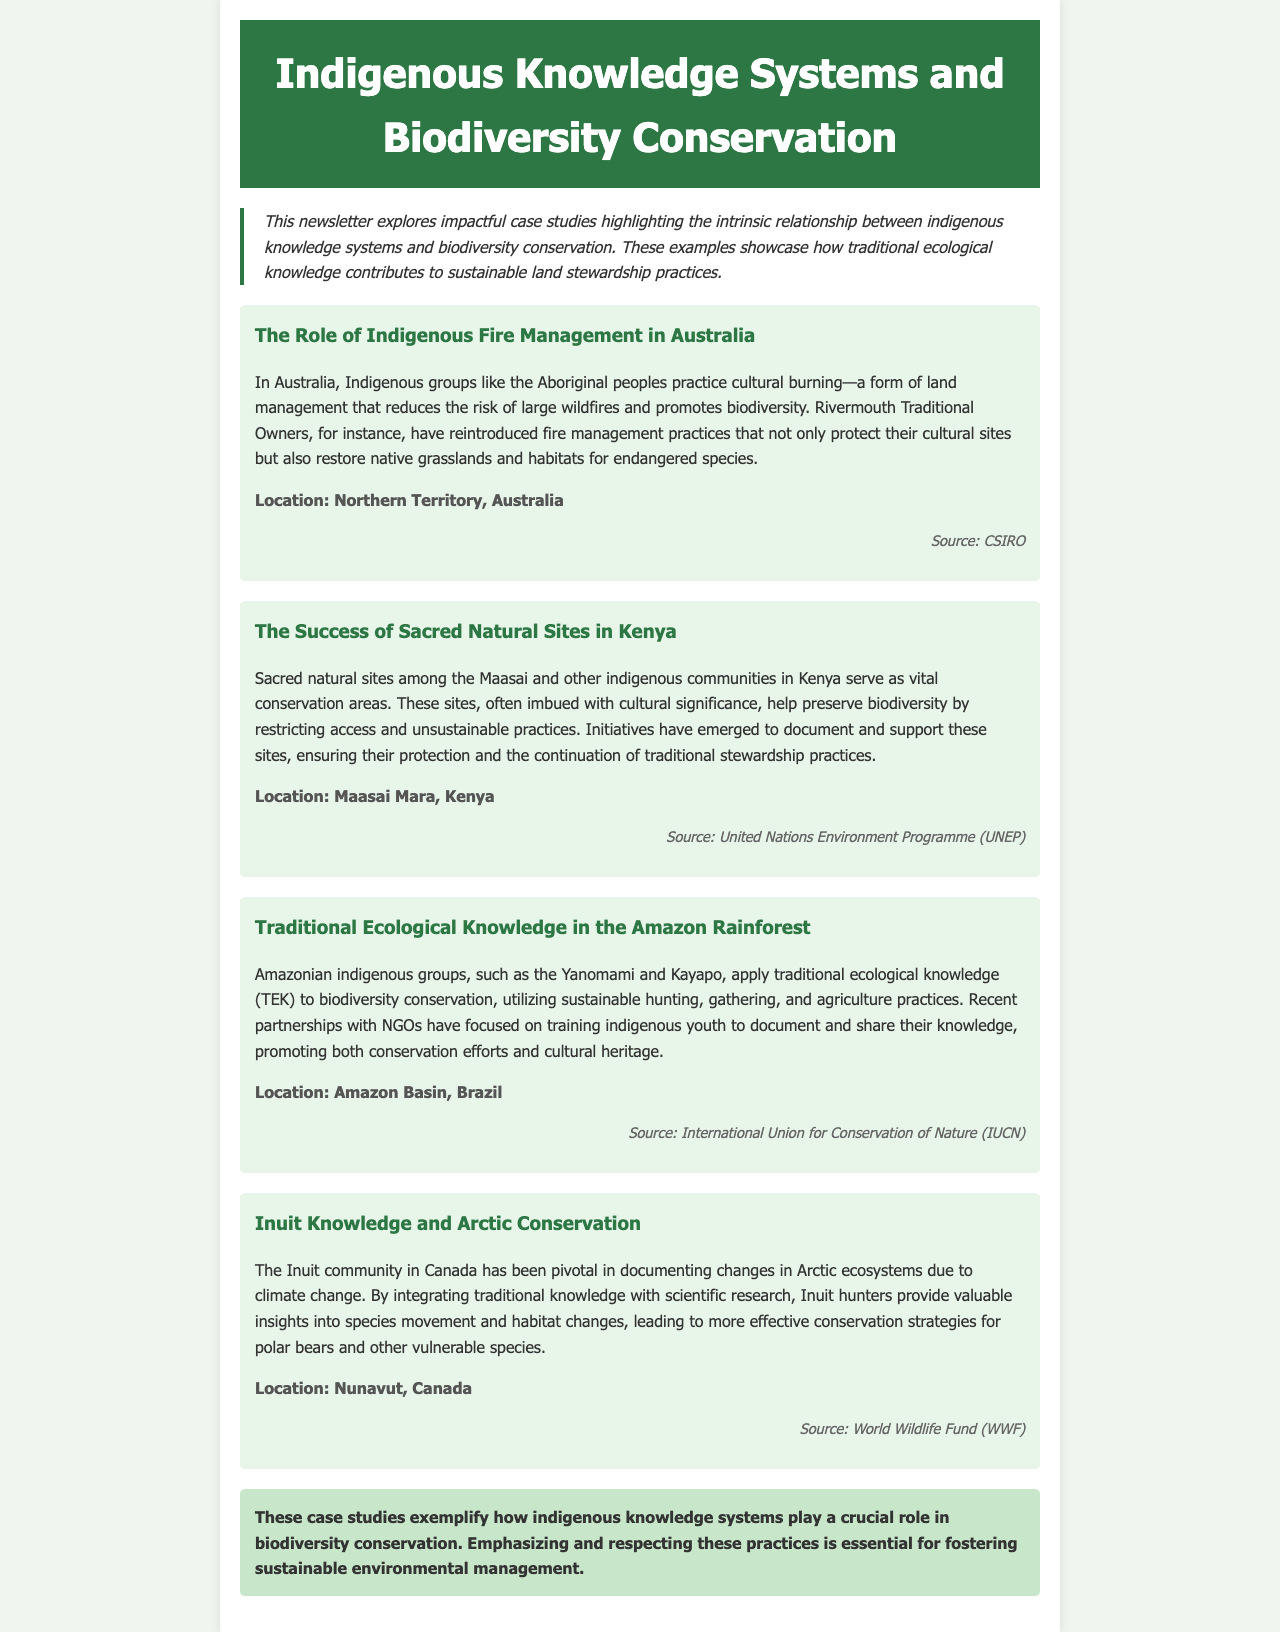What is the title of the newsletter? The title of the newsletter is displayed prominently at the top of the document.
Answer: Indigenous Knowledge Systems and Biodiversity Conservation What practice do Aboriginal peoples in Australia utilize for land management? The document mentions a specific practice used by Aboriginal peoples for managing land and reducing wildfire risks.
Answer: Cultural burning Which indigenous community is highlighted in the case study from the Amazon Rainforest? The specific indigenous groups mentioned in this case study are detailed within the text.
Answer: Yanomami and Kayapo What is one benefit of sacred natural sites in Kenya? The document explains how these sites have a specific cultural significance that aids in biodiversity preservation.
Answer: Preserve biodiversity Which region do the Inuit focus on for documenting ecosystem changes? The location where Inuit are documenting changes due to climate change is stated clearly in the text.
Answer: Nunavut, Canada What organization provided the source for the case study on Inuit Knowledge? The document includes the source of the information presented in the case study related to the Inuit community.
Answer: World Wildlife Fund (WWF) How do Yanomami and Kayapo apply traditional ecological knowledge? The document describes specific sustainable practices utilized by these groups in the Amazon.
Answer: Sustainable hunting, gathering, and agriculture What is emphasized in the conclusion of the newsletter? The conclusion summarizes the overall message about the role of indigenous knowledge in environmental management.
Answer: Respecting indigenous practices 